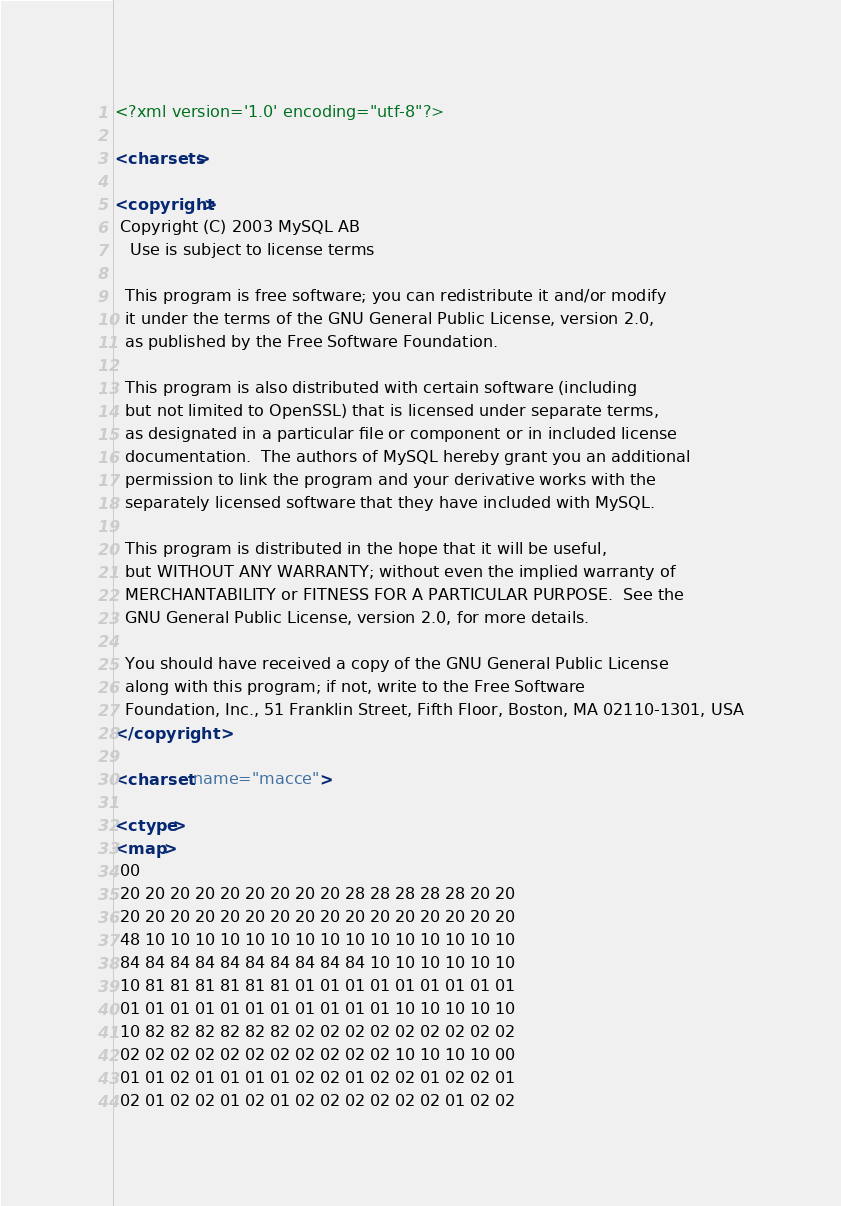Convert code to text. <code><loc_0><loc_0><loc_500><loc_500><_XML_><?xml version='1.0' encoding="utf-8"?>

<charsets>

<copyright>
 Copyright (C) 2003 MySQL AB
   Use is subject to license terms

  This program is free software; you can redistribute it and/or modify
  it under the terms of the GNU General Public License, version 2.0,
  as published by the Free Software Foundation.

  This program is also distributed with certain software (including
  but not limited to OpenSSL) that is licensed under separate terms,
  as designated in a particular file or component or in included license
  documentation.  The authors of MySQL hereby grant you an additional
  permission to link the program and your derivative works with the
  separately licensed software that they have included with MySQL.

  This program is distributed in the hope that it will be useful,
  but WITHOUT ANY WARRANTY; without even the implied warranty of
  MERCHANTABILITY or FITNESS FOR A PARTICULAR PURPOSE.  See the
  GNU General Public License, version 2.0, for more details.

  You should have received a copy of the GNU General Public License
  along with this program; if not, write to the Free Software
  Foundation, Inc., 51 Franklin Street, Fifth Floor, Boston, MA 02110-1301, USA
</copyright>

<charset name="macce">

<ctype>
<map>
 00
 20 20 20 20 20 20 20 20 20 28 28 28 28 28 20 20
 20 20 20 20 20 20 20 20 20 20 20 20 20 20 20 20
 48 10 10 10 10 10 10 10 10 10 10 10 10 10 10 10
 84 84 84 84 84 84 84 84 84 84 10 10 10 10 10 10
 10 81 81 81 81 81 81 01 01 01 01 01 01 01 01 01
 01 01 01 01 01 01 01 01 01 01 01 10 10 10 10 10
 10 82 82 82 82 82 82 02 02 02 02 02 02 02 02 02
 02 02 02 02 02 02 02 02 02 02 02 10 10 10 10 00
 01 01 02 01 01 01 01 02 02 01 02 02 01 02 02 01
 02 01 02 02 01 02 01 02 02 02 02 02 02 01 02 02</code> 